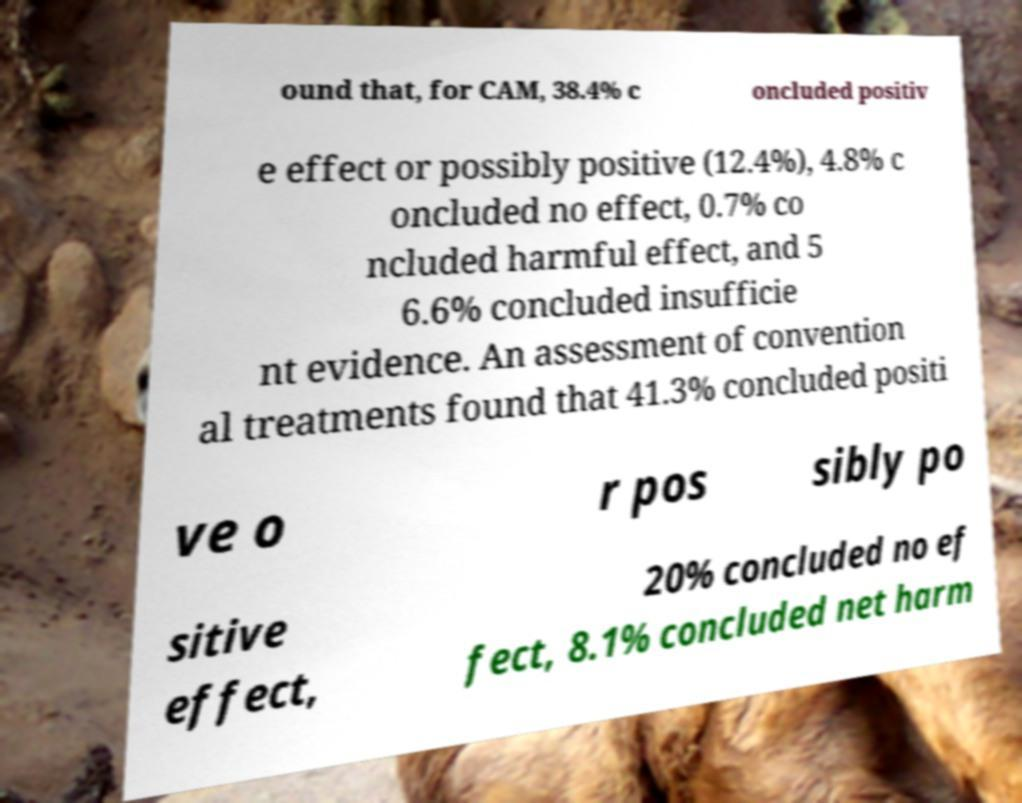Can you accurately transcribe the text from the provided image for me? ound that, for CAM, 38.4% c oncluded positiv e effect or possibly positive (12.4%), 4.8% c oncluded no effect, 0.7% co ncluded harmful effect, and 5 6.6% concluded insufficie nt evidence. An assessment of convention al treatments found that 41.3% concluded positi ve o r pos sibly po sitive effect, 20% concluded no ef fect, 8.1% concluded net harm 